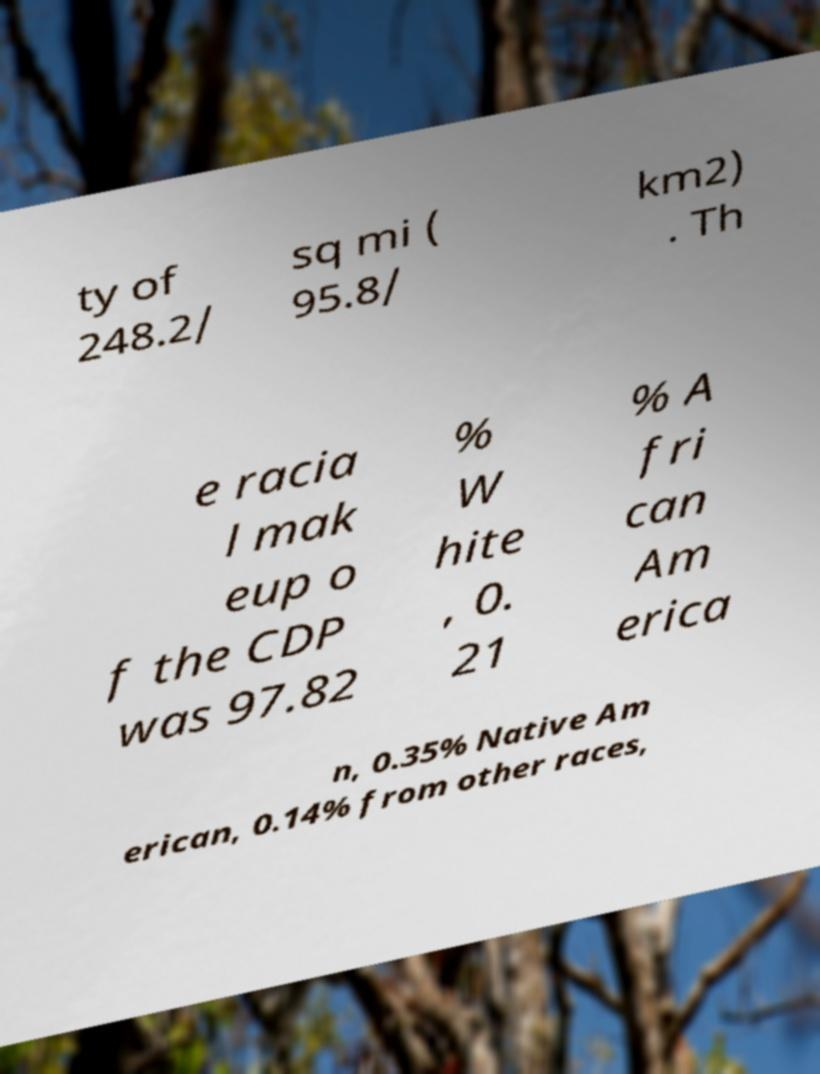There's text embedded in this image that I need extracted. Can you transcribe it verbatim? ty of 248.2/ sq mi ( 95.8/ km2) . Th e racia l mak eup o f the CDP was 97.82 % W hite , 0. 21 % A fri can Am erica n, 0.35% Native Am erican, 0.14% from other races, 